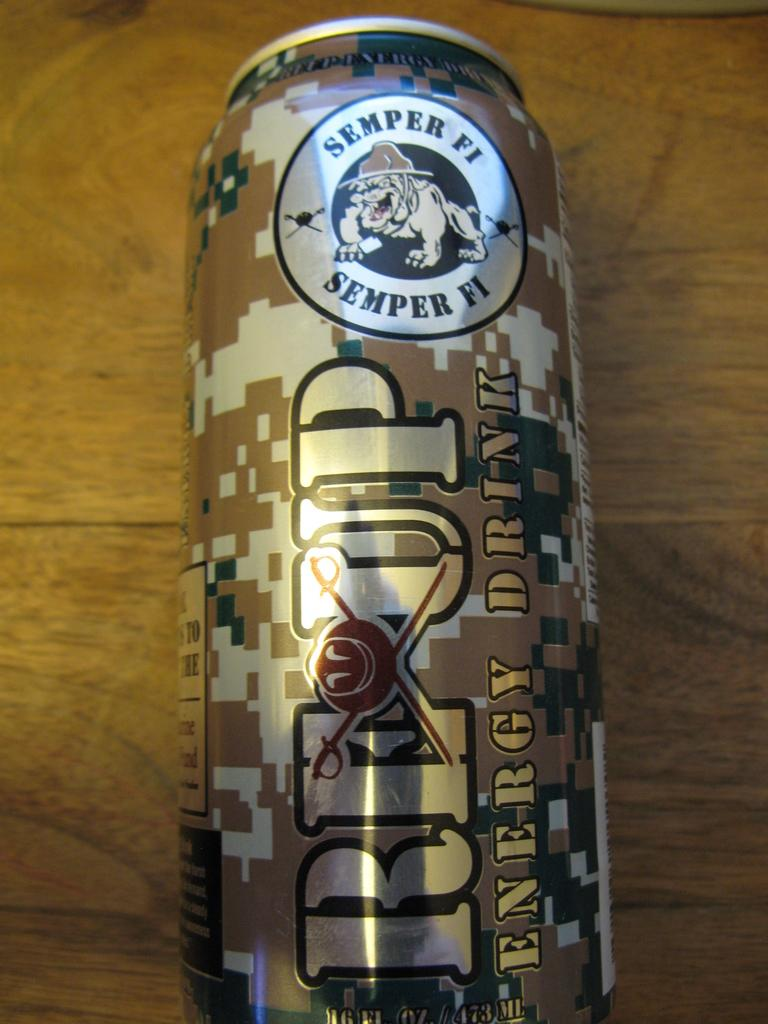<image>
Give a short and clear explanation of the subsequent image. A can is on a wooden table and says Reup Energy Drink on the side. 